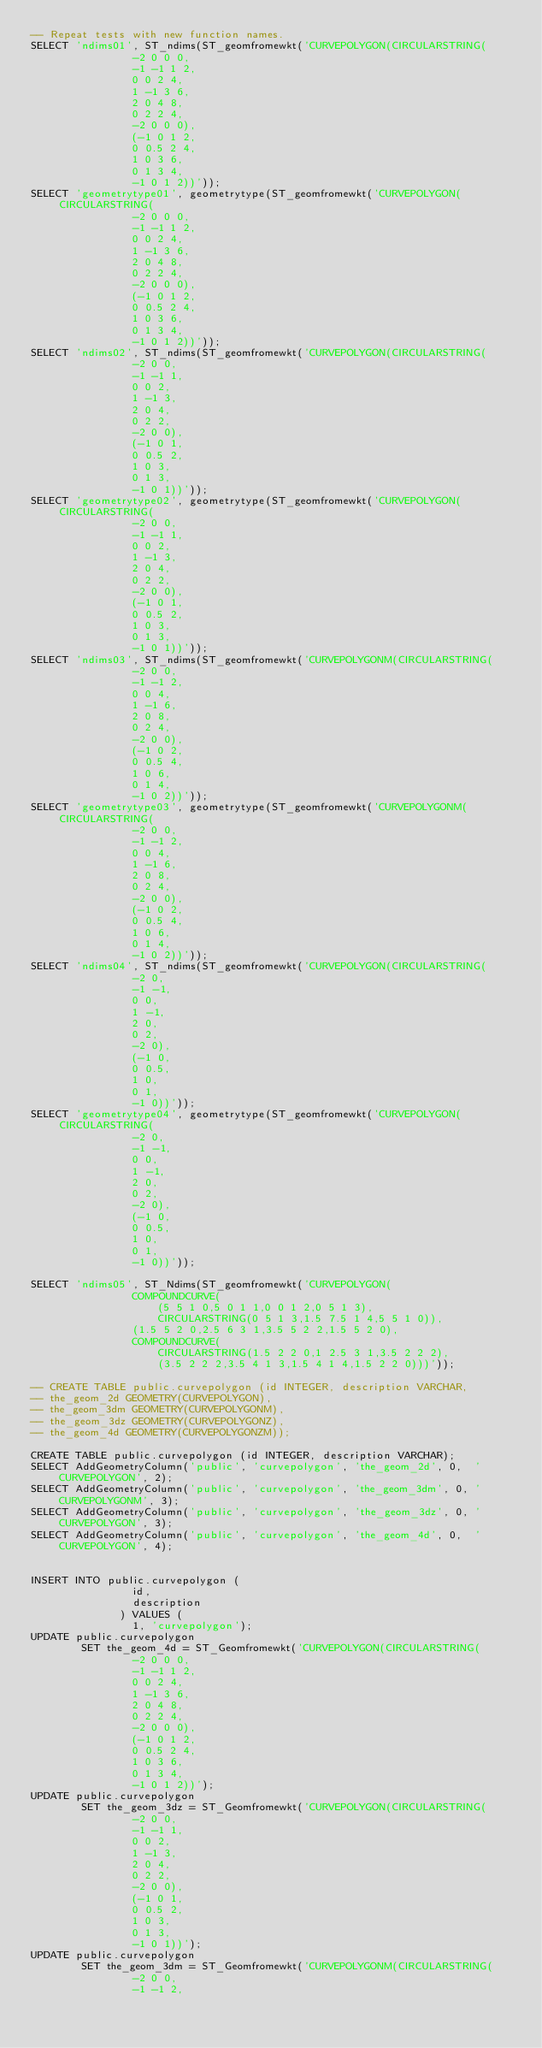Convert code to text. <code><loc_0><loc_0><loc_500><loc_500><_SQL_>-- Repeat tests with new function names.
SELECT 'ndims01', ST_ndims(ST_geomfromewkt('CURVEPOLYGON(CIRCULARSTRING(
                -2 0 0 0,
                -1 -1 1 2,
                0 0 2 4,
                1 -1 3 6,
                2 0 4 8,
                0 2 2 4,
                -2 0 0 0),
                (-1 0 1 2,
                0 0.5 2 4,
                1 0 3 6,
                0 1 3 4,
                -1 0 1 2))'));
SELECT 'geometrytype01', geometrytype(ST_geomfromewkt('CURVEPOLYGON(CIRCULARSTRING(
                -2 0 0 0,
                -1 -1 1 2,
                0 0 2 4,
                1 -1 3 6,
                2 0 4 8,
                0 2 2 4,
                -2 0 0 0),
                (-1 0 1 2,
                0 0.5 2 4,
                1 0 3 6,
                0 1 3 4,
                -1 0 1 2))'));
SELECT 'ndims02', ST_ndims(ST_geomfromewkt('CURVEPOLYGON(CIRCULARSTRING(
                -2 0 0,
                -1 -1 1,
                0 0 2,
                1 -1 3,
                2 0 4,
                0 2 2,
                -2 0 0),
                (-1 0 1,
                0 0.5 2,
                1 0 3,
                0 1 3,
                -1 0 1))'));
SELECT 'geometrytype02', geometrytype(ST_geomfromewkt('CURVEPOLYGON(CIRCULARSTRING(
                -2 0 0,
                -1 -1 1,
                0 0 2,
                1 -1 3,
                2 0 4,
                0 2 2,
                -2 0 0),
                (-1 0 1,
                0 0.5 2,
                1 0 3,
                0 1 3,
                -1 0 1))'));
SELECT 'ndims03', ST_ndims(ST_geomfromewkt('CURVEPOLYGONM(CIRCULARSTRING(
                -2 0 0,
                -1 -1 2,
                0 0 4,
                1 -1 6,
                2 0 8,
                0 2 4,
                -2 0 0),
                (-1 0 2,
                0 0.5 4,
                1 0 6,
                0 1 4,
                -1 0 2))'));
SELECT 'geometrytype03', geometrytype(ST_geomfromewkt('CURVEPOLYGONM(CIRCULARSTRING(
                -2 0 0,
                -1 -1 2,
                0 0 4,
                1 -1 6,
                2 0 8,
                0 2 4,
                -2 0 0),
                (-1 0 2,
                0 0.5 4,
                1 0 6,
                0 1 4,
                -1 0 2))'));
SELECT 'ndims04', ST_ndims(ST_geomfromewkt('CURVEPOLYGON(CIRCULARSTRING(
                -2 0,
                -1 -1,
                0 0,
                1 -1,
                2 0,
                0 2,
                -2 0),
                (-1 0,
                0 0.5,
                1 0,
                0 1,
                -1 0))'));
SELECT 'geometrytype04', geometrytype(ST_geomfromewkt('CURVEPOLYGON(CIRCULARSTRING(
                -2 0,
                -1 -1,
                0 0,
                1 -1,
                2 0,
                0 2,
                -2 0),
                (-1 0,
                0 0.5,
                1 0,
                0 1,
                -1 0))'));
                
SELECT 'ndims05', ST_Ndims(ST_geomfromewkt('CURVEPOLYGON(
                COMPOUNDCURVE(
                    (5 5 1 0,5 0 1 1,0 0 1 2,0 5 1 3),
                    CIRCULARSTRING(0 5 1 3,1.5 7.5 1 4,5 5 1 0)),
                (1.5 5 2 0,2.5 6 3 1,3.5 5 2 2,1.5 5 2 0),
                COMPOUNDCURVE(
                    CIRCULARSTRING(1.5 2 2 0,1 2.5 3 1,3.5 2 2 2),
                    (3.5 2 2 2,3.5 4 1 3,1.5 4 1 4,1.5 2 2 0)))'));

-- CREATE TABLE public.curvepolygon (id INTEGER, description VARCHAR,
-- the_geom_2d GEOMETRY(CURVEPOLYGON),
-- the_geom_3dm GEOMETRY(CURVEPOLYGONM),
-- the_geom_3dz GEOMETRY(CURVEPOLYGONZ),
-- the_geom_4d GEOMETRY(CURVEPOLYGONZM));

CREATE TABLE public.curvepolygon (id INTEGER, description VARCHAR);
SELECT AddGeometryColumn('public', 'curvepolygon', 'the_geom_2d', 0,  'CURVEPOLYGON', 2);
SELECT AddGeometryColumn('public', 'curvepolygon', 'the_geom_3dm', 0, 'CURVEPOLYGONM', 3);
SELECT AddGeometryColumn('public', 'curvepolygon', 'the_geom_3dz', 0, 'CURVEPOLYGON', 3);
SELECT AddGeometryColumn('public', 'curvepolygon', 'the_geom_4d', 0,  'CURVEPOLYGON', 4);


INSERT INTO public.curvepolygon (
                id,
                description
              ) VALUES (
                1, 'curvepolygon');
UPDATE public.curvepolygon
        SET the_geom_4d = ST_Geomfromewkt('CURVEPOLYGON(CIRCULARSTRING(
                -2 0 0 0,
                -1 -1 1 2,
                0 0 2 4,
                1 -1 3 6,
                2 0 4 8,
                0 2 2 4,
                -2 0 0 0),
                (-1 0 1 2,
                0 0.5 2 4,
                1 0 3 6,
                0 1 3 4,
                -1 0 1 2))');
UPDATE public.curvepolygon
        SET the_geom_3dz = ST_Geomfromewkt('CURVEPOLYGON(CIRCULARSTRING(
                -2 0 0,
                -1 -1 1,
                0 0 2,
                1 -1 3,
                2 0 4,
                0 2 2,
                -2 0 0),
                (-1 0 1,
                0 0.5 2,
                1 0 3,
                0 1 3,
                -1 0 1))');
UPDATE public.curvepolygon
        SET the_geom_3dm = ST_Geomfromewkt('CURVEPOLYGONM(CIRCULARSTRING(
                -2 0 0,
                -1 -1 2,</code> 